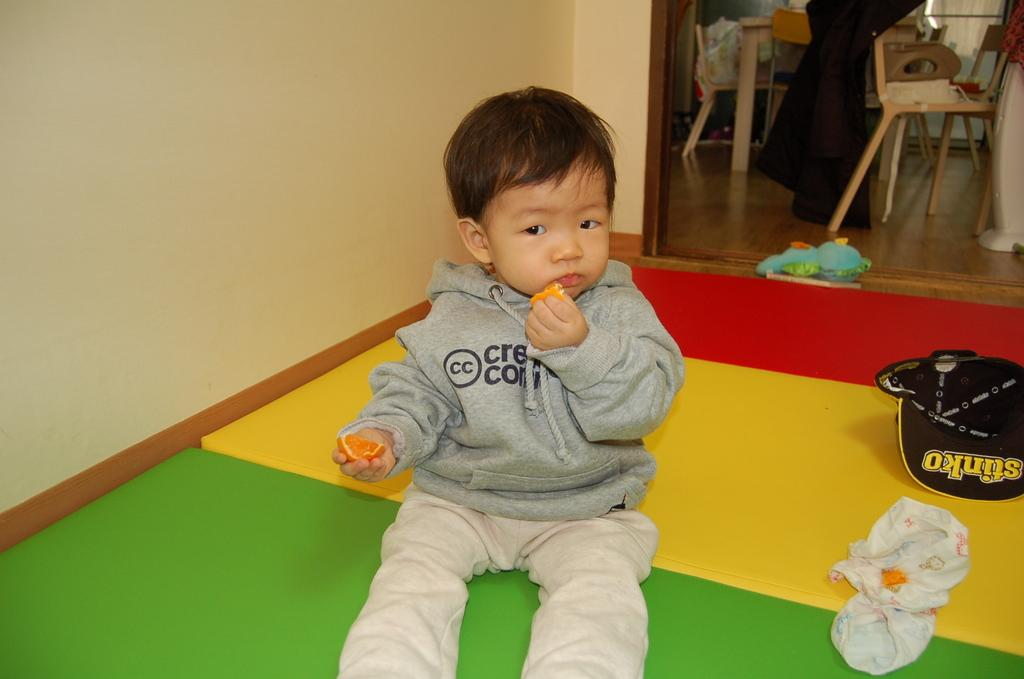What is the boy in the image doing? The boy is sitting in the image. What is the boy holding in the image? The boy is holding a fruit in the image. What type of clothing item is present in the image? There is a diaper and a hat in the image. What type of object is present in the image that might be used for play? There is a toy in the image. What type of furniture is present in the image? There are chairs and a table in the image. What type of structure is present in the image? There is a wall in the image. What type of art can be seen on the wall in the image? There is no art visible on the wall in the image. What type of sport is being played in the image? There is no sport being played in the image. 